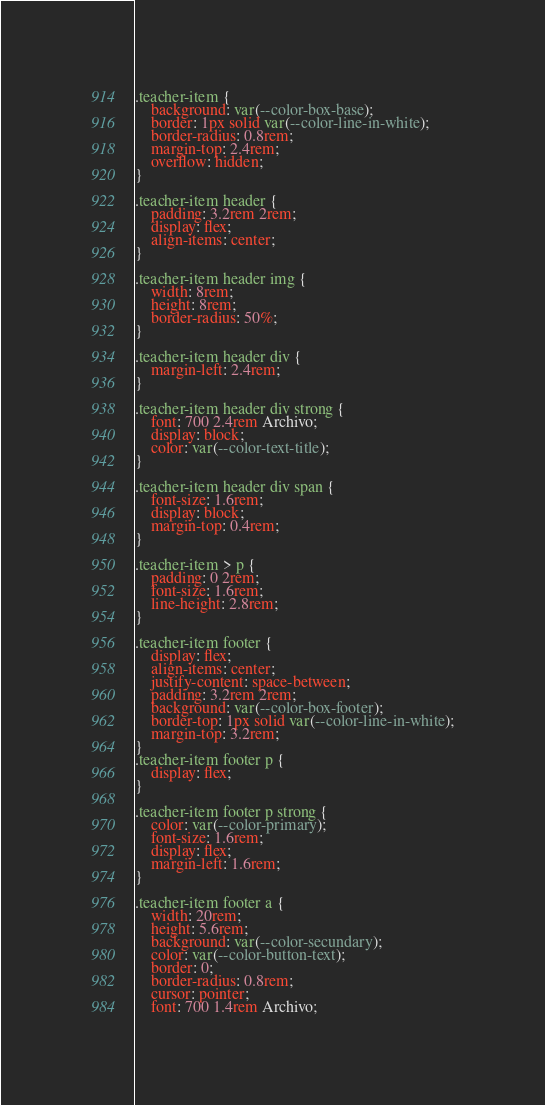<code> <loc_0><loc_0><loc_500><loc_500><_CSS_>.teacher-item {
	background: var(--color-box-base);
	border: 1px solid var(--color-line-in-white);
	border-radius: 0.8rem;
	margin-top: 2.4rem;
	overflow: hidden;
}

.teacher-item header {
	padding: 3.2rem 2rem;
	display: flex;
	align-items: center;
}

.teacher-item header img {
	width: 8rem;
	height: 8rem;
	border-radius: 50%;
}

.teacher-item header div {
	margin-left: 2.4rem;
}

.teacher-item header div strong {
	font: 700 2.4rem Archivo;
	display: block;
	color: var(--color-text-title);
}

.teacher-item header div span {
	font-size: 1.6rem;
	display: block;
	margin-top: 0.4rem;
}

.teacher-item > p {
	padding: 0 2rem;
	font-size: 1.6rem;
	line-height: 2.8rem;
}

.teacher-item footer {
	display: flex;
	align-items: center;
	justify-content: space-between;
	padding: 3.2rem 2rem;
	background: var(--color-box-footer);
	border-top: 1px solid var(--color-line-in-white);
	margin-top: 3.2rem;
}
.teacher-item footer p {
	display: flex;
}

.teacher-item footer p strong {
	color: var(--color-primary);
	font-size: 1.6rem;
	display: flex;
	margin-left: 1.6rem;
}

.teacher-item footer a {
	width: 20rem;
	height: 5.6rem;
	background: var(--color-secundary);
	color: var(--color-button-text);
	border: 0;
	border-radius: 0.8rem;
	cursor: pointer;
	font: 700 1.4rem Archivo;</code> 